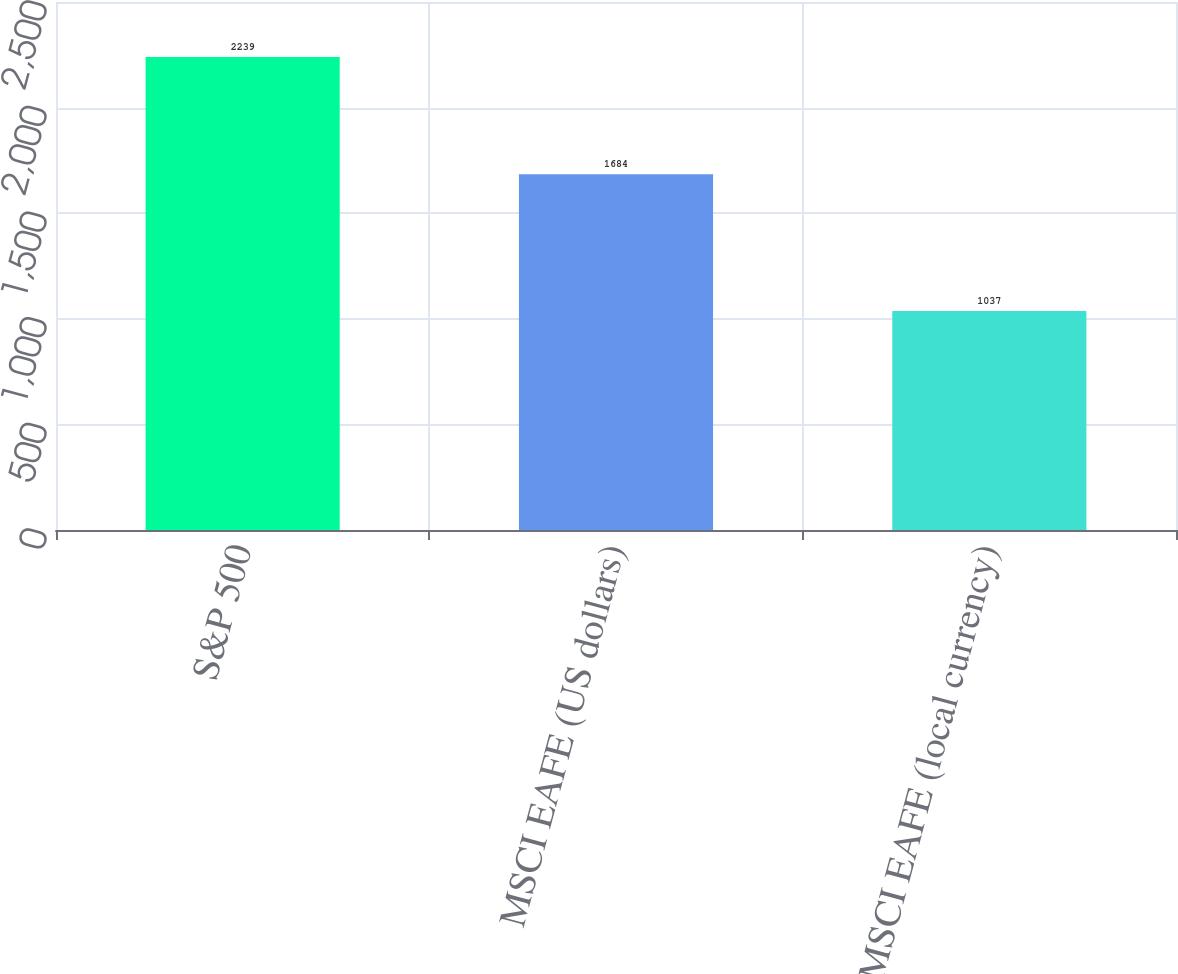Convert chart. <chart><loc_0><loc_0><loc_500><loc_500><bar_chart><fcel>S&P 500<fcel>MSCI EAFE (US dollars)<fcel>MSCI EAFE (local currency)<nl><fcel>2239<fcel>1684<fcel>1037<nl></chart> 